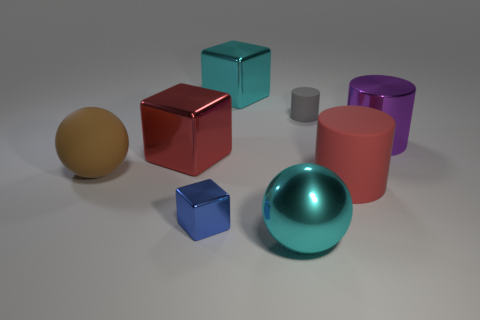What material is the cube that is the same color as the metallic sphere?
Keep it short and to the point. Metal. Is there a red thing of the same size as the blue shiny thing?
Provide a succinct answer. No. Is the number of tiny matte things that are in front of the red rubber object less than the number of small rubber things?
Ensure brevity in your answer.  Yes. Are there fewer things on the right side of the purple metal object than big brown matte balls right of the red cylinder?
Offer a terse response. No. How many balls are matte things or cyan objects?
Your answer should be very brief. 2. Do the cyan object that is in front of the brown matte thing and the big red thing that is on the right side of the big cyan metal block have the same material?
Make the answer very short. No. What shape is the purple metallic thing that is the same size as the red rubber cylinder?
Keep it short and to the point. Cylinder. How many other objects are the same color as the tiny cylinder?
Make the answer very short. 0. How many brown objects are tiny matte things or large cubes?
Provide a short and direct response. 0. Does the small object that is behind the red matte cylinder have the same shape as the object right of the red rubber cylinder?
Offer a very short reply. Yes. 